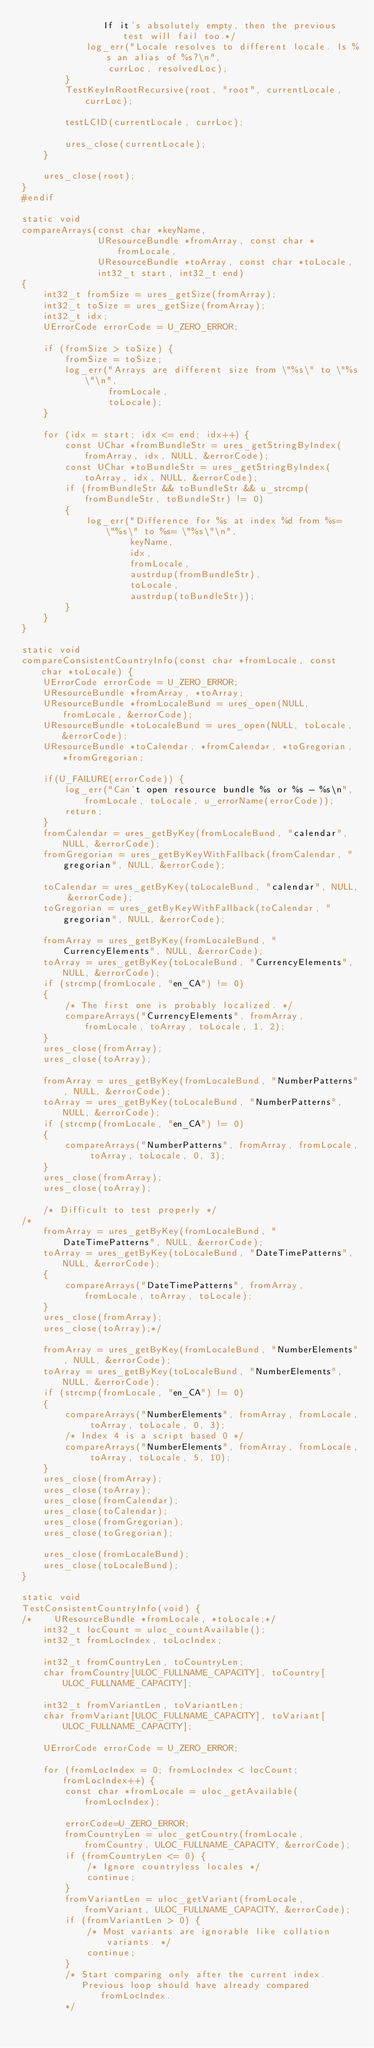<code> <loc_0><loc_0><loc_500><loc_500><_C_>               If it's absolutely empty, then the previous test will fail too.*/
            log_err("Locale resolves to different locale. Is %s an alias of %s?\n",
                currLoc, resolvedLoc);
        }
        TestKeyInRootRecursive(root, "root", currentLocale, currLoc);

        testLCID(currentLocale, currLoc);

        ures_close(currentLocale);
    }

    ures_close(root);
}
#endif

static void
compareArrays(const char *keyName,
              UResourceBundle *fromArray, const char *fromLocale,
              UResourceBundle *toArray, const char *toLocale,
              int32_t start, int32_t end)
{
    int32_t fromSize = ures_getSize(fromArray);
    int32_t toSize = ures_getSize(fromArray);
    int32_t idx;
    UErrorCode errorCode = U_ZERO_ERROR;

    if (fromSize > toSize) {
        fromSize = toSize;
        log_err("Arrays are different size from \"%s\" to \"%s\"\n",
                fromLocale,
                toLocale);
    }

    for (idx = start; idx <= end; idx++) {
        const UChar *fromBundleStr = ures_getStringByIndex(fromArray, idx, NULL, &errorCode);
        const UChar *toBundleStr = ures_getStringByIndex(toArray, idx, NULL, &errorCode);
        if (fromBundleStr && toBundleStr && u_strcmp(fromBundleStr, toBundleStr) != 0)
        {
            log_err("Difference for %s at index %d from %s= \"%s\" to %s= \"%s\"\n",
                    keyName,
                    idx,
                    fromLocale,
                    austrdup(fromBundleStr),
                    toLocale,
                    austrdup(toBundleStr));
        }
    }
}

static void
compareConsistentCountryInfo(const char *fromLocale, const char *toLocale) {
    UErrorCode errorCode = U_ZERO_ERROR;
    UResourceBundle *fromArray, *toArray;
    UResourceBundle *fromLocaleBund = ures_open(NULL, fromLocale, &errorCode);
    UResourceBundle *toLocaleBund = ures_open(NULL, toLocale, &errorCode);
    UResourceBundle *toCalendar, *fromCalendar, *toGregorian, *fromGregorian;

    if(U_FAILURE(errorCode)) {
        log_err("Can't open resource bundle %s or %s - %s\n", fromLocale, toLocale, u_errorName(errorCode));
        return;
    }
    fromCalendar = ures_getByKey(fromLocaleBund, "calendar", NULL, &errorCode);
    fromGregorian = ures_getByKeyWithFallback(fromCalendar, "gregorian", NULL, &errorCode);

    toCalendar = ures_getByKey(toLocaleBund, "calendar", NULL, &errorCode);
    toGregorian = ures_getByKeyWithFallback(toCalendar, "gregorian", NULL, &errorCode);

    fromArray = ures_getByKey(fromLocaleBund, "CurrencyElements", NULL, &errorCode);
    toArray = ures_getByKey(toLocaleBund, "CurrencyElements", NULL, &errorCode);
    if (strcmp(fromLocale, "en_CA") != 0)
    {
        /* The first one is probably localized. */
        compareArrays("CurrencyElements", fromArray, fromLocale, toArray, toLocale, 1, 2);
    }
    ures_close(fromArray);
    ures_close(toArray);

    fromArray = ures_getByKey(fromLocaleBund, "NumberPatterns", NULL, &errorCode);
    toArray = ures_getByKey(toLocaleBund, "NumberPatterns", NULL, &errorCode);
    if (strcmp(fromLocale, "en_CA") != 0)
    {
        compareArrays("NumberPatterns", fromArray, fromLocale, toArray, toLocale, 0, 3);
    }
    ures_close(fromArray);
    ures_close(toArray);

    /* Difficult to test properly */
/*
    fromArray = ures_getByKey(fromLocaleBund, "DateTimePatterns", NULL, &errorCode);
    toArray = ures_getByKey(toLocaleBund, "DateTimePatterns", NULL, &errorCode);
    {
        compareArrays("DateTimePatterns", fromArray, fromLocale, toArray, toLocale);
    }
    ures_close(fromArray);
    ures_close(toArray);*/

    fromArray = ures_getByKey(fromLocaleBund, "NumberElements", NULL, &errorCode);
    toArray = ures_getByKey(toLocaleBund, "NumberElements", NULL, &errorCode);
    if (strcmp(fromLocale, "en_CA") != 0)
    {
        compareArrays("NumberElements", fromArray, fromLocale, toArray, toLocale, 0, 3);
        /* Index 4 is a script based 0 */
        compareArrays("NumberElements", fromArray, fromLocale, toArray, toLocale, 5, 10);
    }
    ures_close(fromArray);
    ures_close(toArray);
    ures_close(fromCalendar);
    ures_close(toCalendar);
    ures_close(fromGregorian);
    ures_close(toGregorian);

    ures_close(fromLocaleBund);
    ures_close(toLocaleBund);
}

static void
TestConsistentCountryInfo(void) {
/*    UResourceBundle *fromLocale, *toLocale;*/
    int32_t locCount = uloc_countAvailable();
    int32_t fromLocIndex, toLocIndex;

    int32_t fromCountryLen, toCountryLen;
    char fromCountry[ULOC_FULLNAME_CAPACITY], toCountry[ULOC_FULLNAME_CAPACITY];

    int32_t fromVariantLen, toVariantLen;
    char fromVariant[ULOC_FULLNAME_CAPACITY], toVariant[ULOC_FULLNAME_CAPACITY];

    UErrorCode errorCode = U_ZERO_ERROR;

    for (fromLocIndex = 0; fromLocIndex < locCount; fromLocIndex++) {
        const char *fromLocale = uloc_getAvailable(fromLocIndex);

        errorCode=U_ZERO_ERROR;
        fromCountryLen = uloc_getCountry(fromLocale, fromCountry, ULOC_FULLNAME_CAPACITY, &errorCode);
        if (fromCountryLen <= 0) {
            /* Ignore countryless locales */
            continue;
        }
        fromVariantLen = uloc_getVariant(fromLocale, fromVariant, ULOC_FULLNAME_CAPACITY, &errorCode);
        if (fromVariantLen > 0) {
            /* Most variants are ignorable like collation variants. */
            continue;
        }
        /* Start comparing only after the current index.
           Previous loop should have already compared fromLocIndex.
        */</code> 